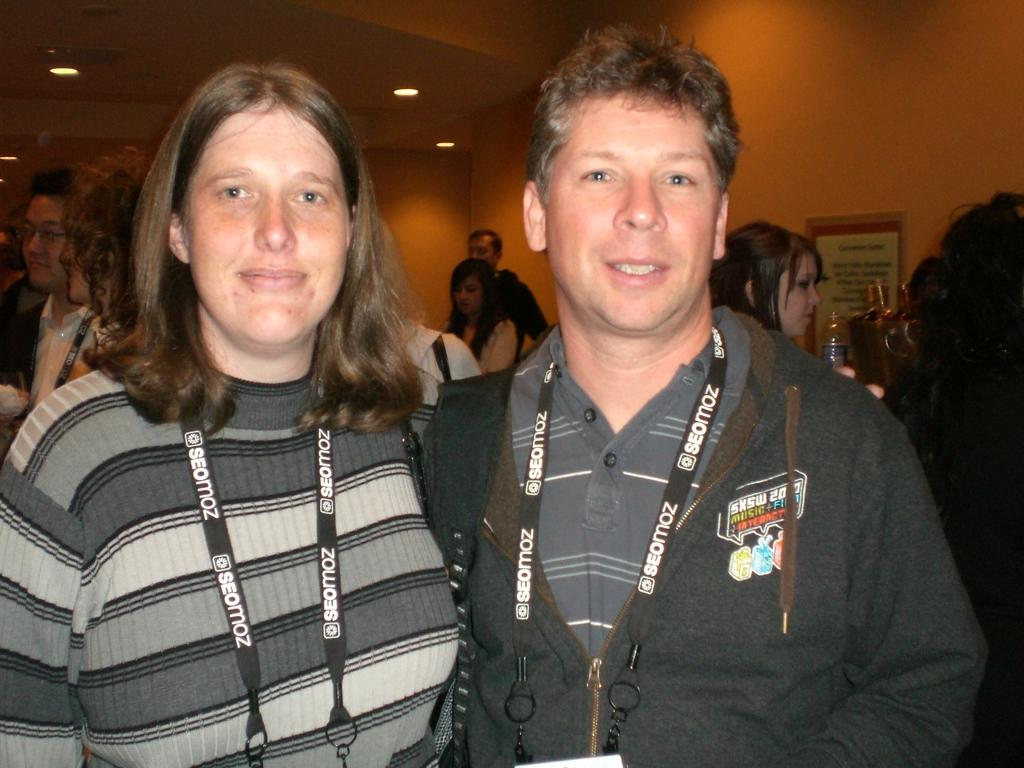How many people are present in the image? There is a man and a woman in the image, making a total of two people. What can be seen in the background of the image? In the background of the image, there is a wall, a ceiling, lights, a board, a bottle, and other objects. Can you describe the people in the image? The image features a man and a woman, but their specific characteristics are not mentioned in the provided facts. What type of kite is being flown by the man in the image? There is no kite present in the image; it features a man and a woman in a setting with various objects in the background. 